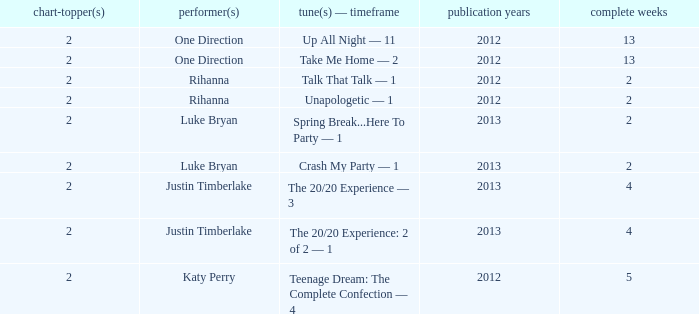What is the longest number of weeks any 1 song was at number #1? 13.0. 